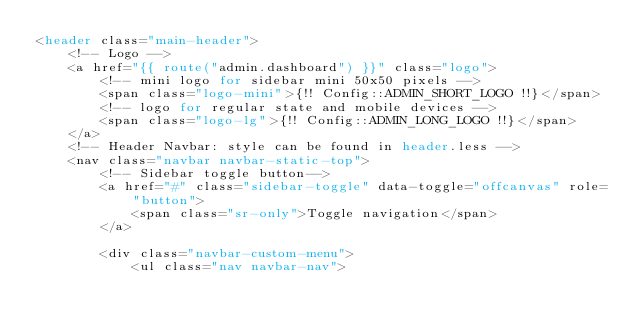Convert code to text. <code><loc_0><loc_0><loc_500><loc_500><_PHP_><header class="main-header">
    <!-- Logo -->
    <a href="{{ route("admin.dashboard") }}" class="logo">
        <!-- mini logo for sidebar mini 50x50 pixels -->
        <span class="logo-mini">{!! Config::ADMIN_SHORT_LOGO !!}</span>
        <!-- logo for regular state and mobile devices -->
        <span class="logo-lg">{!! Config::ADMIN_LONG_LOGO !!}</span>
    </a>
    <!-- Header Navbar: style can be found in header.less -->
    <nav class="navbar navbar-static-top">
        <!-- Sidebar toggle button-->
        <a href="#" class="sidebar-toggle" data-toggle="offcanvas" role="button">
            <span class="sr-only">Toggle navigation</span>
        </a>

        <div class="navbar-custom-menu">
            <ul class="nav navbar-nav"></code> 